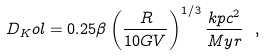Convert formula to latex. <formula><loc_0><loc_0><loc_500><loc_500>D _ { K } o l = 0 . 2 5 \beta \left ( \frac { R } { 1 0 G V } \right ) ^ { 1 / 3 } \frac { k p c ^ { 2 } } { M y r } \ ,</formula> 